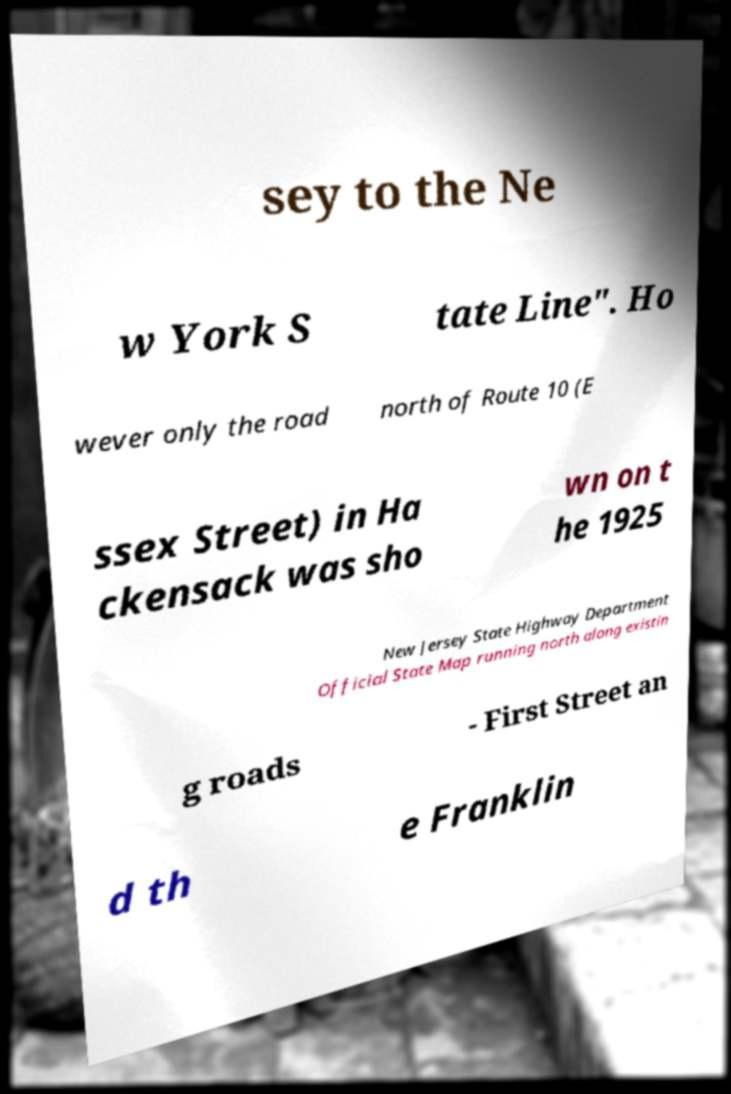For documentation purposes, I need the text within this image transcribed. Could you provide that? sey to the Ne w York S tate Line". Ho wever only the road north of Route 10 (E ssex Street) in Ha ckensack was sho wn on t he 1925 New Jersey State Highway Department Official State Map running north along existin g roads - First Street an d th e Franklin 